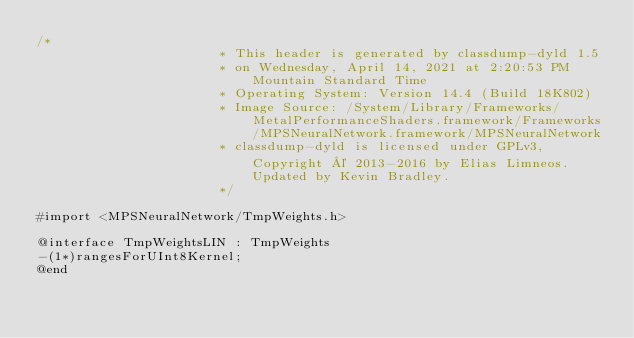<code> <loc_0><loc_0><loc_500><loc_500><_C_>/*
                       * This header is generated by classdump-dyld 1.5
                       * on Wednesday, April 14, 2021 at 2:20:53 PM Mountain Standard Time
                       * Operating System: Version 14.4 (Build 18K802)
                       * Image Source: /System/Library/Frameworks/MetalPerformanceShaders.framework/Frameworks/MPSNeuralNetwork.framework/MPSNeuralNetwork
                       * classdump-dyld is licensed under GPLv3, Copyright © 2013-2016 by Elias Limneos. Updated by Kevin Bradley.
                       */

#import <MPSNeuralNetwork/TmpWeights.h>

@interface TmpWeightsLIN : TmpWeights
-(1*)rangesForUInt8Kernel;
@end

</code> 